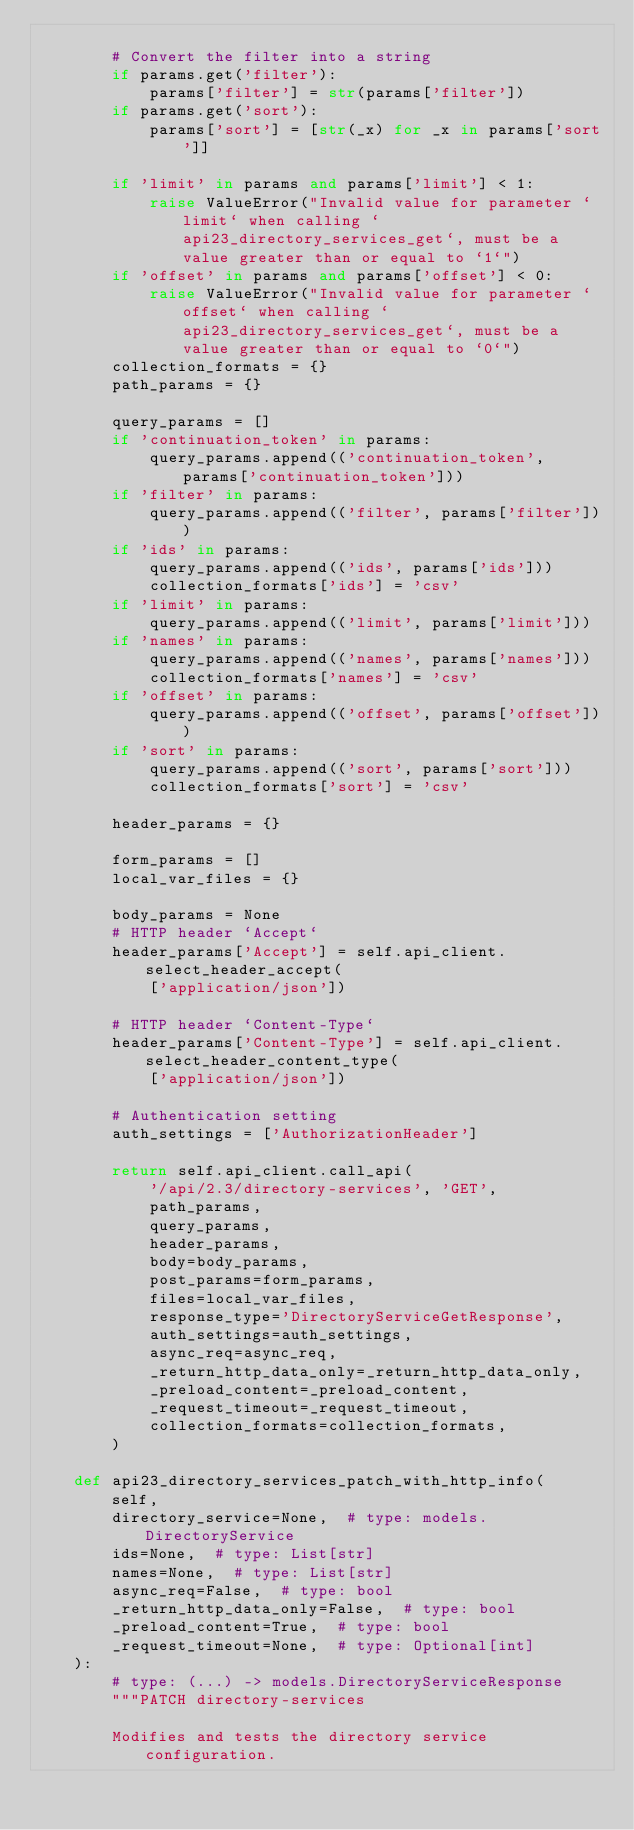Convert code to text. <code><loc_0><loc_0><loc_500><loc_500><_Python_>
        # Convert the filter into a string
        if params.get('filter'):
            params['filter'] = str(params['filter'])
        if params.get('sort'):
            params['sort'] = [str(_x) for _x in params['sort']]

        if 'limit' in params and params['limit'] < 1:
            raise ValueError("Invalid value for parameter `limit` when calling `api23_directory_services_get`, must be a value greater than or equal to `1`")
        if 'offset' in params and params['offset'] < 0:
            raise ValueError("Invalid value for parameter `offset` when calling `api23_directory_services_get`, must be a value greater than or equal to `0`")
        collection_formats = {}
        path_params = {}

        query_params = []
        if 'continuation_token' in params:
            query_params.append(('continuation_token', params['continuation_token']))
        if 'filter' in params:
            query_params.append(('filter', params['filter']))
        if 'ids' in params:
            query_params.append(('ids', params['ids']))
            collection_formats['ids'] = 'csv'
        if 'limit' in params:
            query_params.append(('limit', params['limit']))
        if 'names' in params:
            query_params.append(('names', params['names']))
            collection_formats['names'] = 'csv'
        if 'offset' in params:
            query_params.append(('offset', params['offset']))
        if 'sort' in params:
            query_params.append(('sort', params['sort']))
            collection_formats['sort'] = 'csv'

        header_params = {}

        form_params = []
        local_var_files = {}

        body_params = None
        # HTTP header `Accept`
        header_params['Accept'] = self.api_client.select_header_accept(
            ['application/json'])

        # HTTP header `Content-Type`
        header_params['Content-Type'] = self.api_client.select_header_content_type(
            ['application/json'])

        # Authentication setting
        auth_settings = ['AuthorizationHeader']

        return self.api_client.call_api(
            '/api/2.3/directory-services', 'GET',
            path_params,
            query_params,
            header_params,
            body=body_params,
            post_params=form_params,
            files=local_var_files,
            response_type='DirectoryServiceGetResponse',
            auth_settings=auth_settings,
            async_req=async_req,
            _return_http_data_only=_return_http_data_only,
            _preload_content=_preload_content,
            _request_timeout=_request_timeout,
            collection_formats=collection_formats,
        )

    def api23_directory_services_patch_with_http_info(
        self,
        directory_service=None,  # type: models.DirectoryService
        ids=None,  # type: List[str]
        names=None,  # type: List[str]
        async_req=False,  # type: bool
        _return_http_data_only=False,  # type: bool
        _preload_content=True,  # type: bool
        _request_timeout=None,  # type: Optional[int]
    ):
        # type: (...) -> models.DirectoryServiceResponse
        """PATCH directory-services

        Modifies and tests the directory service configuration.</code> 